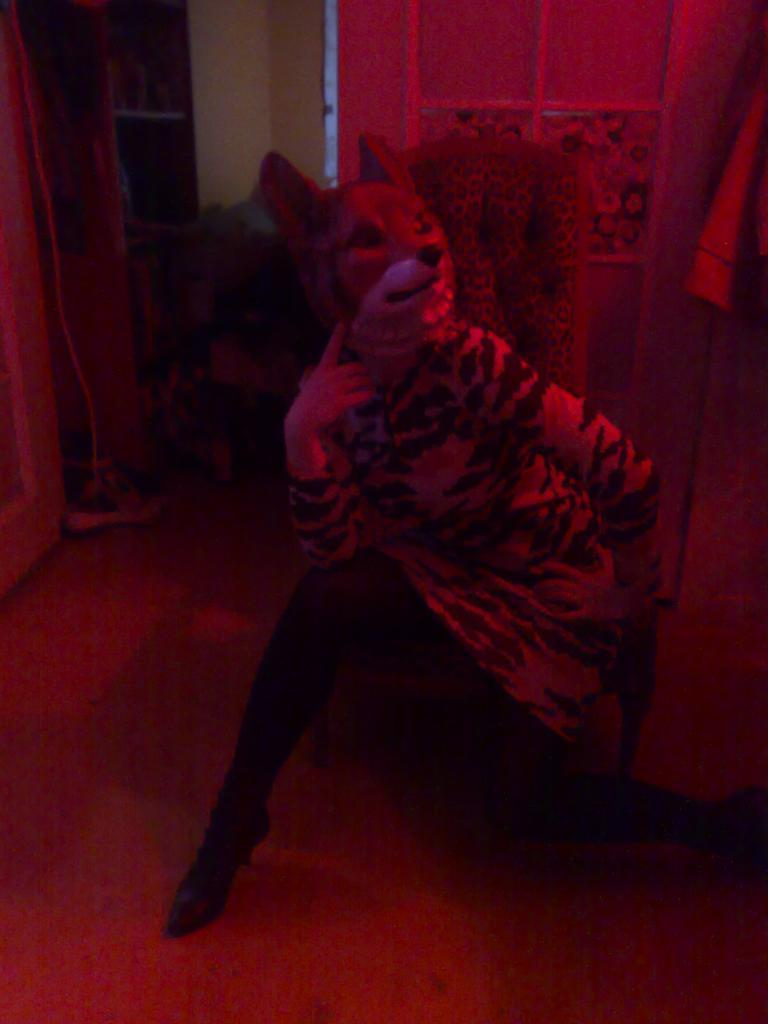Who or what is present in the image? There is a person in the image. What is the person wearing? The person is wearing a mask. What can be seen in the background of the image? There is a chair and other items visible in the background of the image. How does the fan help the person in the image? There is no fan present in the image, so it cannot help the person. 